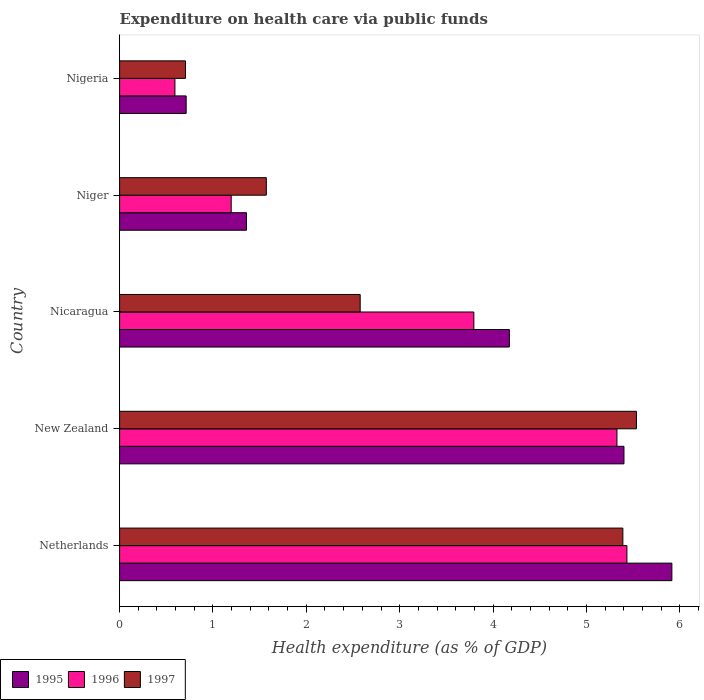How many different coloured bars are there?
Give a very brief answer. 3. How many groups of bars are there?
Keep it short and to the point. 5. Are the number of bars per tick equal to the number of legend labels?
Your answer should be compact. Yes. Are the number of bars on each tick of the Y-axis equal?
Ensure brevity in your answer.  Yes. How many bars are there on the 2nd tick from the top?
Your response must be concise. 3. What is the label of the 3rd group of bars from the top?
Give a very brief answer. Nicaragua. What is the expenditure made on health care in 1996 in Nigeria?
Your answer should be compact. 0.59. Across all countries, what is the maximum expenditure made on health care in 1996?
Offer a very short reply. 5.43. Across all countries, what is the minimum expenditure made on health care in 1997?
Provide a succinct answer. 0.71. In which country was the expenditure made on health care in 1997 minimum?
Offer a very short reply. Nigeria. What is the total expenditure made on health care in 1995 in the graph?
Provide a succinct answer. 17.57. What is the difference between the expenditure made on health care in 1996 in Netherlands and that in Niger?
Make the answer very short. 4.24. What is the difference between the expenditure made on health care in 1996 in Niger and the expenditure made on health care in 1995 in Nigeria?
Offer a very short reply. 0.48. What is the average expenditure made on health care in 1995 per country?
Your answer should be very brief. 3.51. What is the difference between the expenditure made on health care in 1996 and expenditure made on health care in 1997 in Niger?
Your answer should be very brief. -0.38. What is the ratio of the expenditure made on health care in 1996 in New Zealand to that in Nicaragua?
Make the answer very short. 1.4. What is the difference between the highest and the second highest expenditure made on health care in 1995?
Your response must be concise. 0.51. What is the difference between the highest and the lowest expenditure made on health care in 1997?
Provide a short and direct response. 4.83. In how many countries, is the expenditure made on health care in 1995 greater than the average expenditure made on health care in 1995 taken over all countries?
Your answer should be very brief. 3. Is the sum of the expenditure made on health care in 1995 in New Zealand and Nigeria greater than the maximum expenditure made on health care in 1997 across all countries?
Your answer should be very brief. Yes. What does the 2nd bar from the top in New Zealand represents?
Your answer should be compact. 1996. What does the 1st bar from the bottom in New Zealand represents?
Your answer should be very brief. 1995. Is it the case that in every country, the sum of the expenditure made on health care in 1997 and expenditure made on health care in 1996 is greater than the expenditure made on health care in 1995?
Give a very brief answer. Yes. Does the graph contain any zero values?
Provide a short and direct response. No. Where does the legend appear in the graph?
Provide a short and direct response. Bottom left. What is the title of the graph?
Make the answer very short. Expenditure on health care via public funds. Does "1993" appear as one of the legend labels in the graph?
Your answer should be compact. No. What is the label or title of the X-axis?
Your answer should be very brief. Health expenditure (as % of GDP). What is the label or title of the Y-axis?
Provide a succinct answer. Country. What is the Health expenditure (as % of GDP) of 1995 in Netherlands?
Provide a short and direct response. 5.92. What is the Health expenditure (as % of GDP) in 1996 in Netherlands?
Make the answer very short. 5.43. What is the Health expenditure (as % of GDP) of 1997 in Netherlands?
Ensure brevity in your answer.  5.39. What is the Health expenditure (as % of GDP) in 1995 in New Zealand?
Provide a succinct answer. 5.4. What is the Health expenditure (as % of GDP) in 1996 in New Zealand?
Provide a short and direct response. 5.33. What is the Health expenditure (as % of GDP) of 1997 in New Zealand?
Give a very brief answer. 5.54. What is the Health expenditure (as % of GDP) of 1995 in Nicaragua?
Offer a terse response. 4.18. What is the Health expenditure (as % of GDP) of 1996 in Nicaragua?
Give a very brief answer. 3.79. What is the Health expenditure (as % of GDP) of 1997 in Nicaragua?
Make the answer very short. 2.58. What is the Health expenditure (as % of GDP) of 1995 in Niger?
Offer a very short reply. 1.36. What is the Health expenditure (as % of GDP) of 1996 in Niger?
Your response must be concise. 1.2. What is the Health expenditure (as % of GDP) in 1997 in Niger?
Make the answer very short. 1.57. What is the Health expenditure (as % of GDP) of 1995 in Nigeria?
Keep it short and to the point. 0.71. What is the Health expenditure (as % of GDP) of 1996 in Nigeria?
Make the answer very short. 0.59. What is the Health expenditure (as % of GDP) of 1997 in Nigeria?
Your answer should be very brief. 0.71. Across all countries, what is the maximum Health expenditure (as % of GDP) in 1995?
Give a very brief answer. 5.92. Across all countries, what is the maximum Health expenditure (as % of GDP) of 1996?
Make the answer very short. 5.43. Across all countries, what is the maximum Health expenditure (as % of GDP) of 1997?
Offer a terse response. 5.54. Across all countries, what is the minimum Health expenditure (as % of GDP) in 1995?
Provide a short and direct response. 0.71. Across all countries, what is the minimum Health expenditure (as % of GDP) in 1996?
Ensure brevity in your answer.  0.59. Across all countries, what is the minimum Health expenditure (as % of GDP) in 1997?
Keep it short and to the point. 0.71. What is the total Health expenditure (as % of GDP) in 1995 in the graph?
Your response must be concise. 17.57. What is the total Health expenditure (as % of GDP) in 1996 in the graph?
Keep it short and to the point. 16.34. What is the total Health expenditure (as % of GDP) in 1997 in the graph?
Make the answer very short. 15.78. What is the difference between the Health expenditure (as % of GDP) in 1995 in Netherlands and that in New Zealand?
Your answer should be compact. 0.51. What is the difference between the Health expenditure (as % of GDP) in 1996 in Netherlands and that in New Zealand?
Offer a terse response. 0.11. What is the difference between the Health expenditure (as % of GDP) of 1997 in Netherlands and that in New Zealand?
Give a very brief answer. -0.15. What is the difference between the Health expenditure (as % of GDP) in 1995 in Netherlands and that in Nicaragua?
Make the answer very short. 1.74. What is the difference between the Health expenditure (as % of GDP) in 1996 in Netherlands and that in Nicaragua?
Ensure brevity in your answer.  1.64. What is the difference between the Health expenditure (as % of GDP) of 1997 in Netherlands and that in Nicaragua?
Make the answer very short. 2.81. What is the difference between the Health expenditure (as % of GDP) in 1995 in Netherlands and that in Niger?
Your response must be concise. 4.56. What is the difference between the Health expenditure (as % of GDP) of 1996 in Netherlands and that in Niger?
Give a very brief answer. 4.24. What is the difference between the Health expenditure (as % of GDP) of 1997 in Netherlands and that in Niger?
Ensure brevity in your answer.  3.82. What is the difference between the Health expenditure (as % of GDP) in 1995 in Netherlands and that in Nigeria?
Ensure brevity in your answer.  5.2. What is the difference between the Health expenditure (as % of GDP) of 1996 in Netherlands and that in Nigeria?
Make the answer very short. 4.84. What is the difference between the Health expenditure (as % of GDP) in 1997 in Netherlands and that in Nigeria?
Keep it short and to the point. 4.69. What is the difference between the Health expenditure (as % of GDP) of 1995 in New Zealand and that in Nicaragua?
Your response must be concise. 1.23. What is the difference between the Health expenditure (as % of GDP) of 1996 in New Zealand and that in Nicaragua?
Your answer should be compact. 1.53. What is the difference between the Health expenditure (as % of GDP) in 1997 in New Zealand and that in Nicaragua?
Offer a terse response. 2.96. What is the difference between the Health expenditure (as % of GDP) in 1995 in New Zealand and that in Niger?
Your answer should be very brief. 4.04. What is the difference between the Health expenditure (as % of GDP) of 1996 in New Zealand and that in Niger?
Provide a short and direct response. 4.13. What is the difference between the Health expenditure (as % of GDP) of 1997 in New Zealand and that in Niger?
Offer a terse response. 3.96. What is the difference between the Health expenditure (as % of GDP) of 1995 in New Zealand and that in Nigeria?
Your answer should be compact. 4.69. What is the difference between the Health expenditure (as % of GDP) of 1996 in New Zealand and that in Nigeria?
Provide a succinct answer. 4.74. What is the difference between the Health expenditure (as % of GDP) of 1997 in New Zealand and that in Nigeria?
Give a very brief answer. 4.83. What is the difference between the Health expenditure (as % of GDP) in 1995 in Nicaragua and that in Niger?
Provide a succinct answer. 2.82. What is the difference between the Health expenditure (as % of GDP) of 1996 in Nicaragua and that in Niger?
Ensure brevity in your answer.  2.6. What is the difference between the Health expenditure (as % of GDP) of 1997 in Nicaragua and that in Niger?
Provide a short and direct response. 1.01. What is the difference between the Health expenditure (as % of GDP) of 1995 in Nicaragua and that in Nigeria?
Your answer should be compact. 3.46. What is the difference between the Health expenditure (as % of GDP) of 1996 in Nicaragua and that in Nigeria?
Make the answer very short. 3.2. What is the difference between the Health expenditure (as % of GDP) in 1997 in Nicaragua and that in Nigeria?
Ensure brevity in your answer.  1.87. What is the difference between the Health expenditure (as % of GDP) in 1995 in Niger and that in Nigeria?
Your answer should be compact. 0.65. What is the difference between the Health expenditure (as % of GDP) in 1996 in Niger and that in Nigeria?
Your response must be concise. 0.6. What is the difference between the Health expenditure (as % of GDP) of 1997 in Niger and that in Nigeria?
Your answer should be very brief. 0.87. What is the difference between the Health expenditure (as % of GDP) in 1995 in Netherlands and the Health expenditure (as % of GDP) in 1996 in New Zealand?
Your answer should be very brief. 0.59. What is the difference between the Health expenditure (as % of GDP) of 1995 in Netherlands and the Health expenditure (as % of GDP) of 1997 in New Zealand?
Keep it short and to the point. 0.38. What is the difference between the Health expenditure (as % of GDP) in 1996 in Netherlands and the Health expenditure (as % of GDP) in 1997 in New Zealand?
Offer a terse response. -0.1. What is the difference between the Health expenditure (as % of GDP) in 1995 in Netherlands and the Health expenditure (as % of GDP) in 1996 in Nicaragua?
Keep it short and to the point. 2.12. What is the difference between the Health expenditure (as % of GDP) of 1995 in Netherlands and the Health expenditure (as % of GDP) of 1997 in Nicaragua?
Your answer should be compact. 3.34. What is the difference between the Health expenditure (as % of GDP) in 1996 in Netherlands and the Health expenditure (as % of GDP) in 1997 in Nicaragua?
Offer a very short reply. 2.86. What is the difference between the Health expenditure (as % of GDP) in 1995 in Netherlands and the Health expenditure (as % of GDP) in 1996 in Niger?
Provide a short and direct response. 4.72. What is the difference between the Health expenditure (as % of GDP) in 1995 in Netherlands and the Health expenditure (as % of GDP) in 1997 in Niger?
Provide a succinct answer. 4.34. What is the difference between the Health expenditure (as % of GDP) of 1996 in Netherlands and the Health expenditure (as % of GDP) of 1997 in Niger?
Keep it short and to the point. 3.86. What is the difference between the Health expenditure (as % of GDP) in 1995 in Netherlands and the Health expenditure (as % of GDP) in 1996 in Nigeria?
Make the answer very short. 5.32. What is the difference between the Health expenditure (as % of GDP) in 1995 in Netherlands and the Health expenditure (as % of GDP) in 1997 in Nigeria?
Your answer should be very brief. 5.21. What is the difference between the Health expenditure (as % of GDP) of 1996 in Netherlands and the Health expenditure (as % of GDP) of 1997 in Nigeria?
Ensure brevity in your answer.  4.73. What is the difference between the Health expenditure (as % of GDP) of 1995 in New Zealand and the Health expenditure (as % of GDP) of 1996 in Nicaragua?
Give a very brief answer. 1.61. What is the difference between the Health expenditure (as % of GDP) of 1995 in New Zealand and the Health expenditure (as % of GDP) of 1997 in Nicaragua?
Your answer should be very brief. 2.83. What is the difference between the Health expenditure (as % of GDP) of 1996 in New Zealand and the Health expenditure (as % of GDP) of 1997 in Nicaragua?
Offer a terse response. 2.75. What is the difference between the Health expenditure (as % of GDP) in 1995 in New Zealand and the Health expenditure (as % of GDP) in 1996 in Niger?
Your response must be concise. 4.21. What is the difference between the Health expenditure (as % of GDP) of 1995 in New Zealand and the Health expenditure (as % of GDP) of 1997 in Niger?
Ensure brevity in your answer.  3.83. What is the difference between the Health expenditure (as % of GDP) of 1996 in New Zealand and the Health expenditure (as % of GDP) of 1997 in Niger?
Your response must be concise. 3.76. What is the difference between the Health expenditure (as % of GDP) in 1995 in New Zealand and the Health expenditure (as % of GDP) in 1996 in Nigeria?
Offer a terse response. 4.81. What is the difference between the Health expenditure (as % of GDP) of 1995 in New Zealand and the Health expenditure (as % of GDP) of 1997 in Nigeria?
Ensure brevity in your answer.  4.7. What is the difference between the Health expenditure (as % of GDP) in 1996 in New Zealand and the Health expenditure (as % of GDP) in 1997 in Nigeria?
Provide a short and direct response. 4.62. What is the difference between the Health expenditure (as % of GDP) in 1995 in Nicaragua and the Health expenditure (as % of GDP) in 1996 in Niger?
Your answer should be very brief. 2.98. What is the difference between the Health expenditure (as % of GDP) in 1995 in Nicaragua and the Health expenditure (as % of GDP) in 1997 in Niger?
Your answer should be very brief. 2.6. What is the difference between the Health expenditure (as % of GDP) of 1996 in Nicaragua and the Health expenditure (as % of GDP) of 1997 in Niger?
Offer a terse response. 2.22. What is the difference between the Health expenditure (as % of GDP) of 1995 in Nicaragua and the Health expenditure (as % of GDP) of 1996 in Nigeria?
Your answer should be compact. 3.58. What is the difference between the Health expenditure (as % of GDP) of 1995 in Nicaragua and the Health expenditure (as % of GDP) of 1997 in Nigeria?
Give a very brief answer. 3.47. What is the difference between the Health expenditure (as % of GDP) in 1996 in Nicaragua and the Health expenditure (as % of GDP) in 1997 in Nigeria?
Give a very brief answer. 3.09. What is the difference between the Health expenditure (as % of GDP) in 1995 in Niger and the Health expenditure (as % of GDP) in 1996 in Nigeria?
Give a very brief answer. 0.77. What is the difference between the Health expenditure (as % of GDP) of 1995 in Niger and the Health expenditure (as % of GDP) of 1997 in Nigeria?
Your response must be concise. 0.65. What is the difference between the Health expenditure (as % of GDP) in 1996 in Niger and the Health expenditure (as % of GDP) in 1997 in Nigeria?
Your answer should be very brief. 0.49. What is the average Health expenditure (as % of GDP) in 1995 per country?
Ensure brevity in your answer.  3.51. What is the average Health expenditure (as % of GDP) in 1996 per country?
Ensure brevity in your answer.  3.27. What is the average Health expenditure (as % of GDP) of 1997 per country?
Offer a very short reply. 3.16. What is the difference between the Health expenditure (as % of GDP) in 1995 and Health expenditure (as % of GDP) in 1996 in Netherlands?
Offer a terse response. 0.48. What is the difference between the Health expenditure (as % of GDP) of 1995 and Health expenditure (as % of GDP) of 1997 in Netherlands?
Provide a short and direct response. 0.53. What is the difference between the Health expenditure (as % of GDP) in 1996 and Health expenditure (as % of GDP) in 1997 in Netherlands?
Ensure brevity in your answer.  0.04. What is the difference between the Health expenditure (as % of GDP) of 1995 and Health expenditure (as % of GDP) of 1996 in New Zealand?
Offer a terse response. 0.08. What is the difference between the Health expenditure (as % of GDP) of 1995 and Health expenditure (as % of GDP) of 1997 in New Zealand?
Provide a succinct answer. -0.13. What is the difference between the Health expenditure (as % of GDP) of 1996 and Health expenditure (as % of GDP) of 1997 in New Zealand?
Your answer should be very brief. -0.21. What is the difference between the Health expenditure (as % of GDP) in 1995 and Health expenditure (as % of GDP) in 1996 in Nicaragua?
Your answer should be compact. 0.38. What is the difference between the Health expenditure (as % of GDP) of 1995 and Health expenditure (as % of GDP) of 1997 in Nicaragua?
Make the answer very short. 1.6. What is the difference between the Health expenditure (as % of GDP) of 1996 and Health expenditure (as % of GDP) of 1997 in Nicaragua?
Offer a very short reply. 1.22. What is the difference between the Health expenditure (as % of GDP) in 1995 and Health expenditure (as % of GDP) in 1996 in Niger?
Your response must be concise. 0.16. What is the difference between the Health expenditure (as % of GDP) of 1995 and Health expenditure (as % of GDP) of 1997 in Niger?
Offer a very short reply. -0.21. What is the difference between the Health expenditure (as % of GDP) in 1996 and Health expenditure (as % of GDP) in 1997 in Niger?
Your answer should be very brief. -0.38. What is the difference between the Health expenditure (as % of GDP) of 1995 and Health expenditure (as % of GDP) of 1996 in Nigeria?
Your answer should be very brief. 0.12. What is the difference between the Health expenditure (as % of GDP) of 1995 and Health expenditure (as % of GDP) of 1997 in Nigeria?
Give a very brief answer. 0.01. What is the difference between the Health expenditure (as % of GDP) of 1996 and Health expenditure (as % of GDP) of 1997 in Nigeria?
Offer a very short reply. -0.11. What is the ratio of the Health expenditure (as % of GDP) of 1995 in Netherlands to that in New Zealand?
Offer a very short reply. 1.09. What is the ratio of the Health expenditure (as % of GDP) of 1997 in Netherlands to that in New Zealand?
Keep it short and to the point. 0.97. What is the ratio of the Health expenditure (as % of GDP) of 1995 in Netherlands to that in Nicaragua?
Make the answer very short. 1.42. What is the ratio of the Health expenditure (as % of GDP) in 1996 in Netherlands to that in Nicaragua?
Your answer should be compact. 1.43. What is the ratio of the Health expenditure (as % of GDP) of 1997 in Netherlands to that in Nicaragua?
Your answer should be very brief. 2.09. What is the ratio of the Health expenditure (as % of GDP) of 1995 in Netherlands to that in Niger?
Your answer should be compact. 4.35. What is the ratio of the Health expenditure (as % of GDP) of 1996 in Netherlands to that in Niger?
Make the answer very short. 4.55. What is the ratio of the Health expenditure (as % of GDP) of 1997 in Netherlands to that in Niger?
Keep it short and to the point. 3.43. What is the ratio of the Health expenditure (as % of GDP) in 1995 in Netherlands to that in Nigeria?
Give a very brief answer. 8.3. What is the ratio of the Health expenditure (as % of GDP) in 1996 in Netherlands to that in Nigeria?
Provide a short and direct response. 9.17. What is the ratio of the Health expenditure (as % of GDP) of 1997 in Netherlands to that in Nigeria?
Make the answer very short. 7.64. What is the ratio of the Health expenditure (as % of GDP) in 1995 in New Zealand to that in Nicaragua?
Keep it short and to the point. 1.29. What is the ratio of the Health expenditure (as % of GDP) in 1996 in New Zealand to that in Nicaragua?
Your response must be concise. 1.4. What is the ratio of the Health expenditure (as % of GDP) in 1997 in New Zealand to that in Nicaragua?
Ensure brevity in your answer.  2.15. What is the ratio of the Health expenditure (as % of GDP) of 1995 in New Zealand to that in Niger?
Your response must be concise. 3.98. What is the ratio of the Health expenditure (as % of GDP) in 1996 in New Zealand to that in Niger?
Offer a terse response. 4.46. What is the ratio of the Health expenditure (as % of GDP) of 1997 in New Zealand to that in Niger?
Offer a terse response. 3.52. What is the ratio of the Health expenditure (as % of GDP) in 1995 in New Zealand to that in Nigeria?
Your answer should be compact. 7.58. What is the ratio of the Health expenditure (as % of GDP) in 1996 in New Zealand to that in Nigeria?
Ensure brevity in your answer.  8.99. What is the ratio of the Health expenditure (as % of GDP) in 1997 in New Zealand to that in Nigeria?
Offer a very short reply. 7.85. What is the ratio of the Health expenditure (as % of GDP) in 1995 in Nicaragua to that in Niger?
Provide a short and direct response. 3.07. What is the ratio of the Health expenditure (as % of GDP) in 1996 in Nicaragua to that in Niger?
Ensure brevity in your answer.  3.17. What is the ratio of the Health expenditure (as % of GDP) in 1997 in Nicaragua to that in Niger?
Offer a terse response. 1.64. What is the ratio of the Health expenditure (as % of GDP) of 1995 in Nicaragua to that in Nigeria?
Offer a terse response. 5.86. What is the ratio of the Health expenditure (as % of GDP) of 1996 in Nicaragua to that in Nigeria?
Keep it short and to the point. 6.4. What is the ratio of the Health expenditure (as % of GDP) in 1997 in Nicaragua to that in Nigeria?
Provide a short and direct response. 3.65. What is the ratio of the Health expenditure (as % of GDP) in 1995 in Niger to that in Nigeria?
Provide a short and direct response. 1.91. What is the ratio of the Health expenditure (as % of GDP) in 1996 in Niger to that in Nigeria?
Provide a succinct answer. 2.02. What is the ratio of the Health expenditure (as % of GDP) of 1997 in Niger to that in Nigeria?
Provide a succinct answer. 2.23. What is the difference between the highest and the second highest Health expenditure (as % of GDP) of 1995?
Your answer should be compact. 0.51. What is the difference between the highest and the second highest Health expenditure (as % of GDP) in 1996?
Provide a succinct answer. 0.11. What is the difference between the highest and the second highest Health expenditure (as % of GDP) of 1997?
Offer a terse response. 0.15. What is the difference between the highest and the lowest Health expenditure (as % of GDP) of 1995?
Offer a terse response. 5.2. What is the difference between the highest and the lowest Health expenditure (as % of GDP) of 1996?
Make the answer very short. 4.84. What is the difference between the highest and the lowest Health expenditure (as % of GDP) of 1997?
Your answer should be compact. 4.83. 